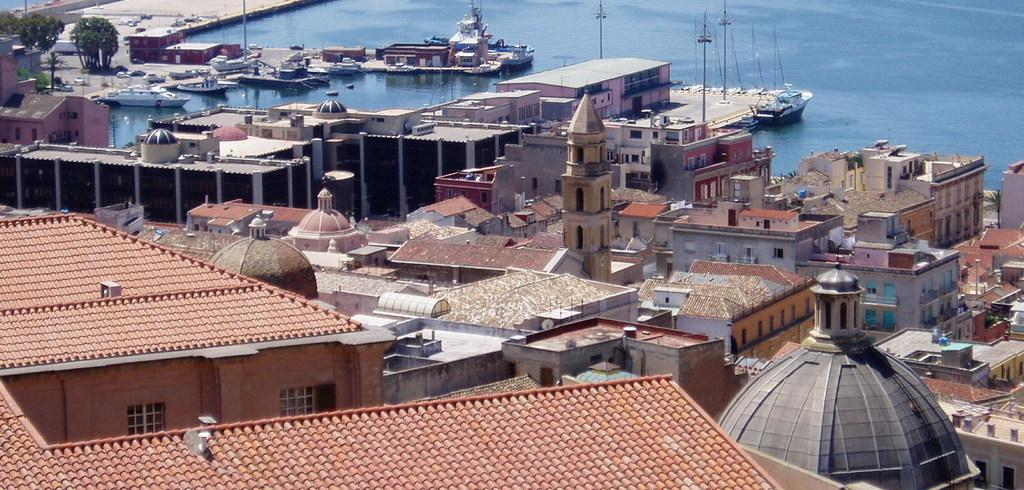What structures are located in the front of the image? There are buildings in the front of the image. What can be seen in the background of the image? There is water, ships, and trees visible in the background of the image. Can you see a giraffe in the image? No, there is no giraffe present in the image. What type of trip is being taken by the people on the ships in the image? The image does not provide any information about the people on the ships or their trip, so it cannot be determined from the image. 